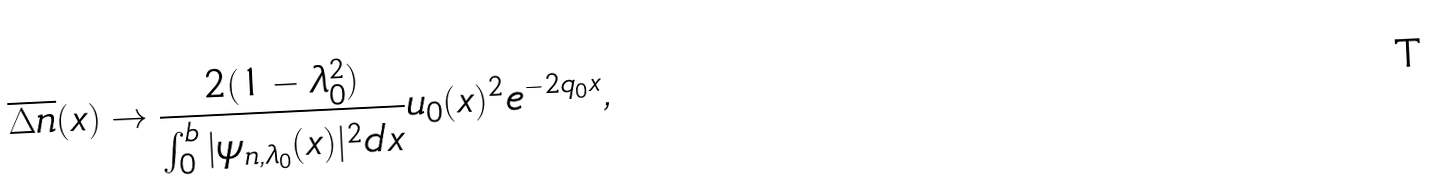Convert formula to latex. <formula><loc_0><loc_0><loc_500><loc_500>\overline { \Delta n } ( x ) \rightarrow \frac { 2 ( 1 - \lambda _ { 0 } ^ { 2 } ) } { \int _ { 0 } ^ { b } | \psi _ { n , \lambda _ { 0 } } ( x ) | ^ { 2 } d x } u _ { 0 } ( x ) ^ { 2 } e ^ { - 2 q _ { 0 } x } ,</formula> 